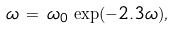Convert formula to latex. <formula><loc_0><loc_0><loc_500><loc_500>\omega \, = \, \omega _ { 0 } \, \exp ( - 2 . 3 \omega ) ,</formula> 